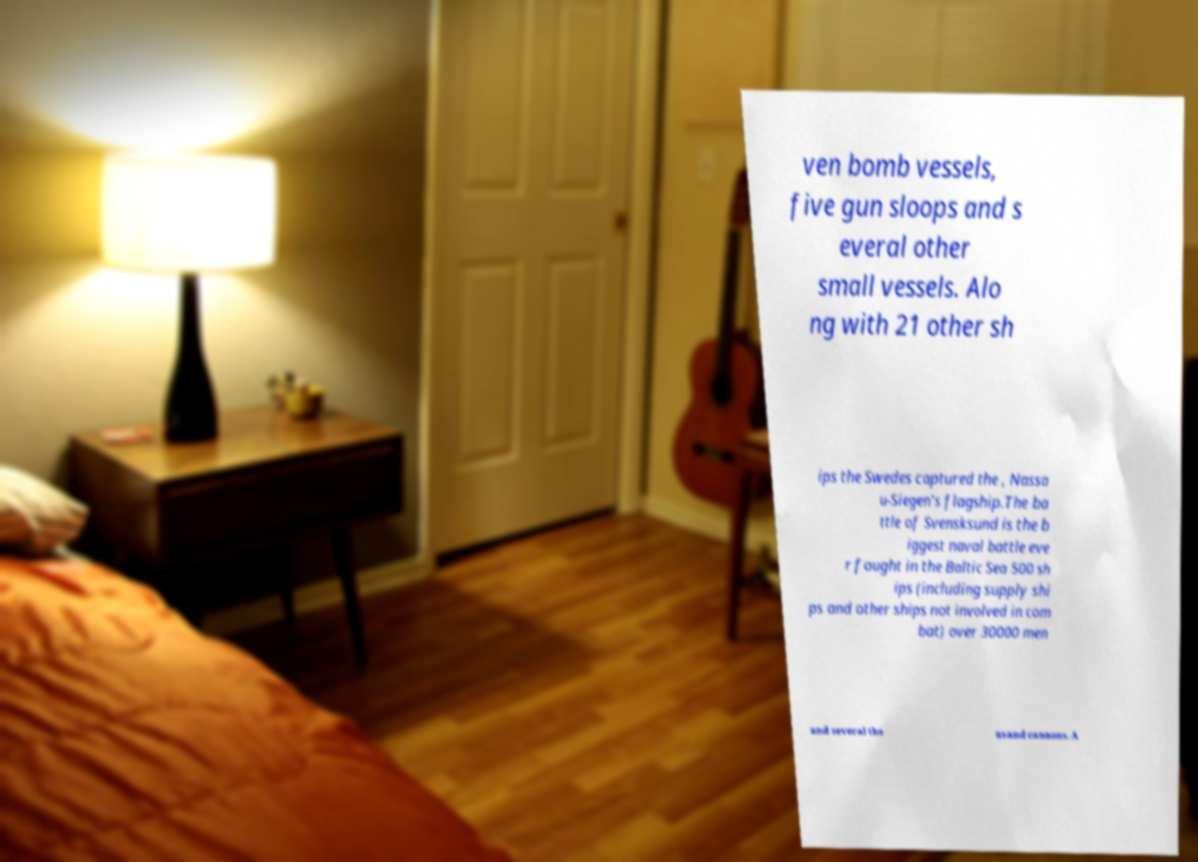Please read and relay the text visible in this image. What does it say? ven bomb vessels, five gun sloops and s everal other small vessels. Alo ng with 21 other sh ips the Swedes captured the , Nassa u-Siegen's flagship.The ba ttle of Svensksund is the b iggest naval battle eve r fought in the Baltic Sea 500 sh ips (including supply shi ps and other ships not involved in com bat) over 30000 men and several tho usand cannons. A 